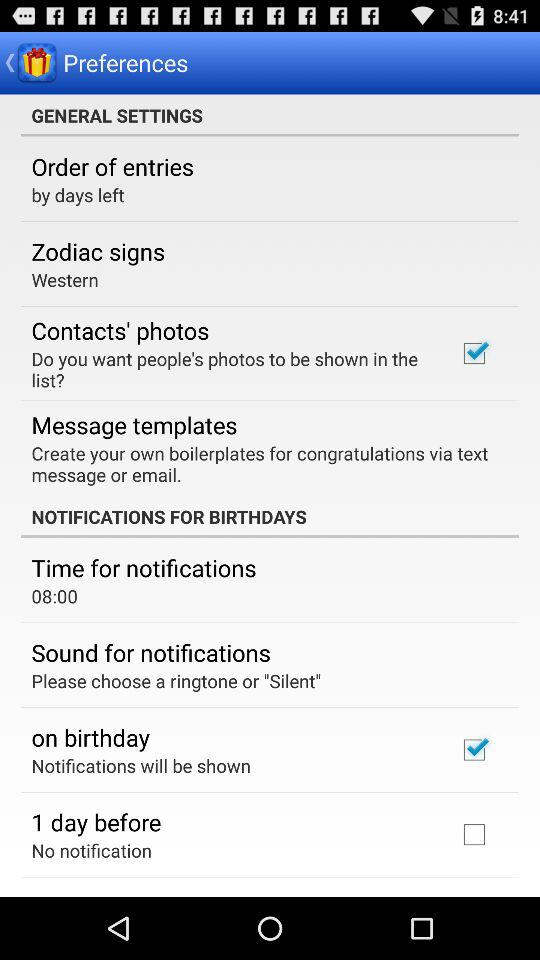Which option is marked as checked? The options that are marked as checked are "Contacts' photos" and "on birthday". 